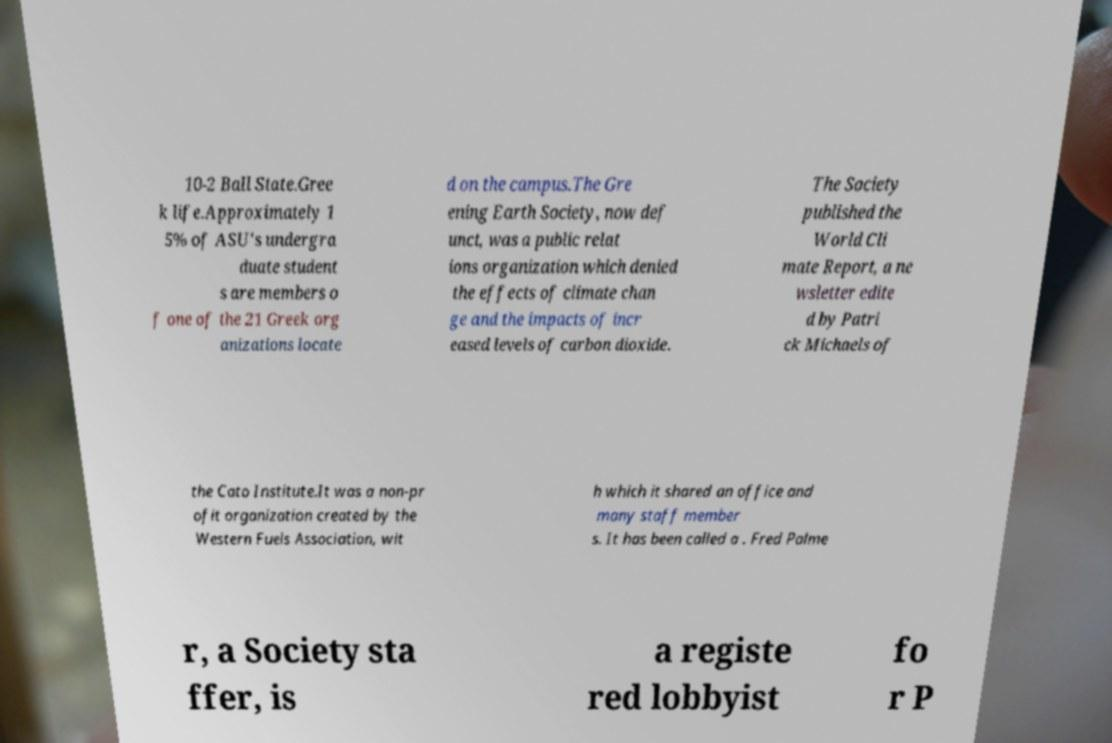Could you extract and type out the text from this image? 10-2 Ball State.Gree k life.Approximately 1 5% of ASU's undergra duate student s are members o f one of the 21 Greek org anizations locate d on the campus.The Gre ening Earth Society, now def unct, was a public relat ions organization which denied the effects of climate chan ge and the impacts of incr eased levels of carbon dioxide. The Society published the World Cli mate Report, a ne wsletter edite d by Patri ck Michaels of the Cato Institute.It was a non-pr ofit organization created by the Western Fuels Association, wit h which it shared an office and many staff member s. It has been called a . Fred Palme r, a Society sta ffer, is a registe red lobbyist fo r P 